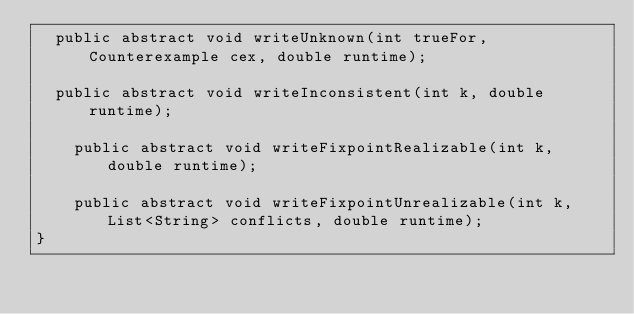<code> <loc_0><loc_0><loc_500><loc_500><_Java_>	public abstract void writeUnknown(int trueFor, Counterexample cex, double runtime);

	public abstract void writeInconsistent(int k, double runtime);

    public abstract void writeFixpointRealizable(int k, double runtime);

    public abstract void writeFixpointUnrealizable(int k, List<String> conflicts, double runtime);
}
</code> 